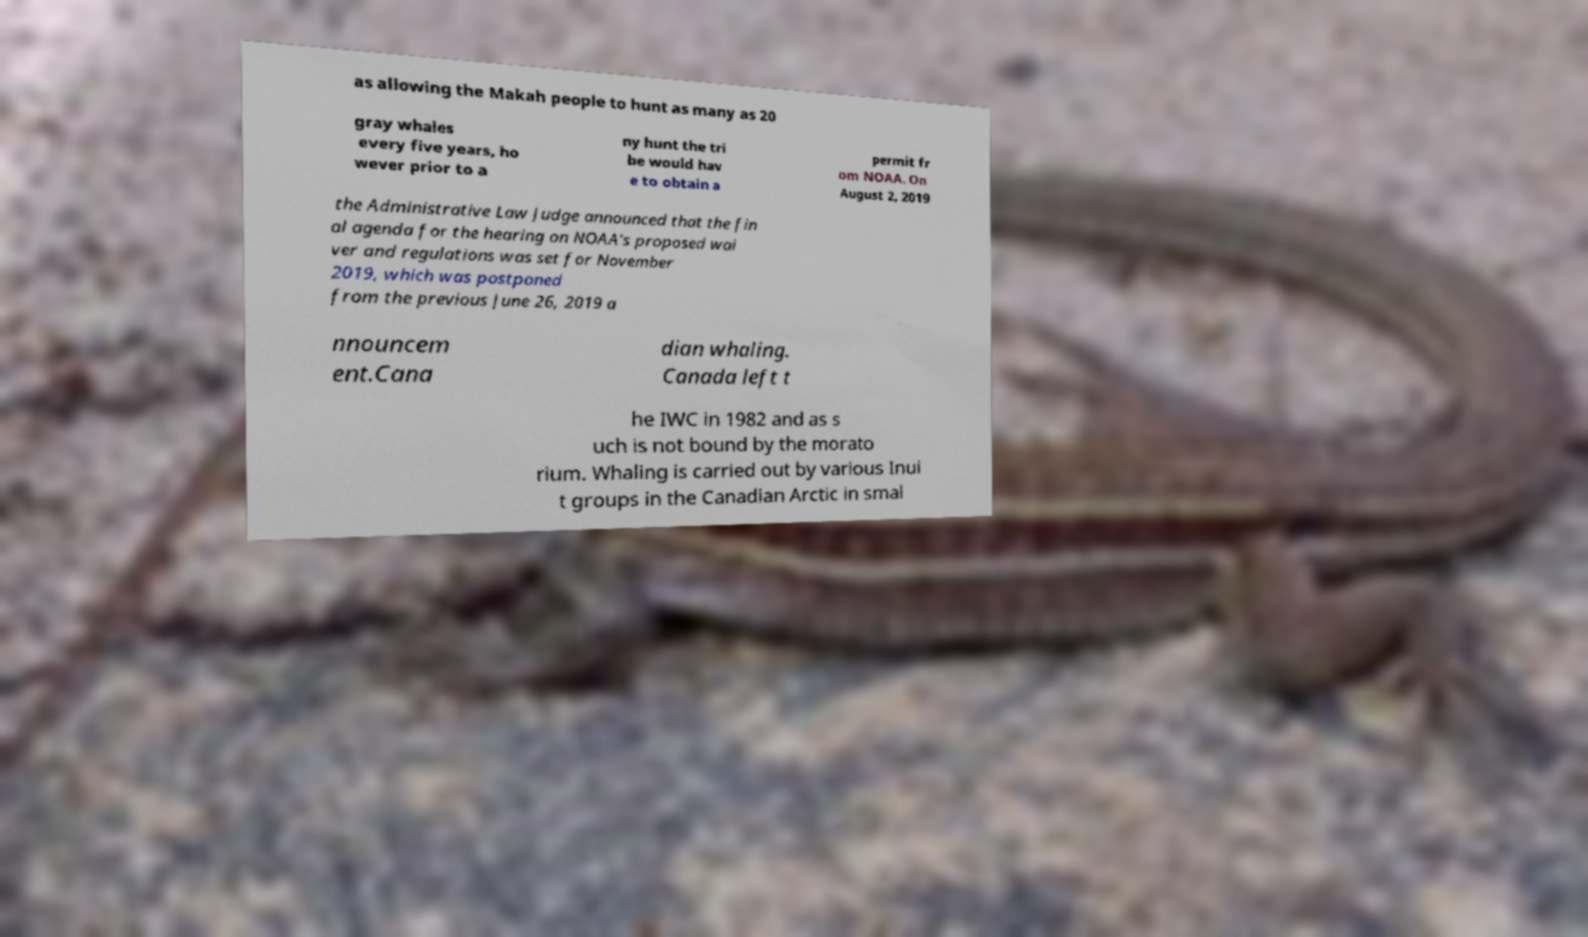What messages or text are displayed in this image? I need them in a readable, typed format. as allowing the Makah people to hunt as many as 20 gray whales every five years, ho wever prior to a ny hunt the tri be would hav e to obtain a permit fr om NOAA. On August 2, 2019 the Administrative Law Judge announced that the fin al agenda for the hearing on NOAA's proposed wai ver and regulations was set for November 2019, which was postponed from the previous June 26, 2019 a nnouncem ent.Cana dian whaling. Canada left t he IWC in 1982 and as s uch is not bound by the morato rium. Whaling is carried out by various Inui t groups in the Canadian Arctic in smal 